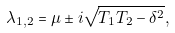Convert formula to latex. <formula><loc_0><loc_0><loc_500><loc_500>\lambda _ { 1 , 2 } = \mu \pm i \sqrt { T _ { 1 } T _ { 2 } - \delta ^ { 2 } } ,</formula> 